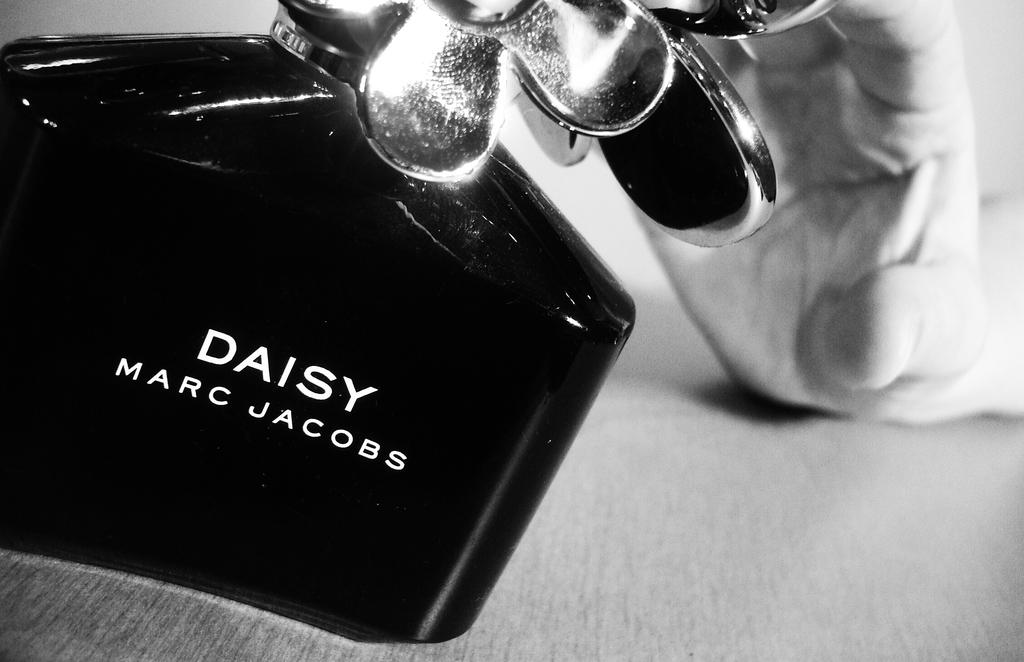<image>
Describe the image concisely. A small bottle of Daisy by Marc Jacobs being picked up by a person. 